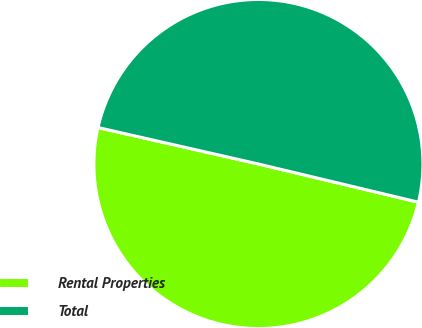<chart> <loc_0><loc_0><loc_500><loc_500><pie_chart><fcel>Rental Properties<fcel>Total<nl><fcel>49.83%<fcel>50.17%<nl></chart> 